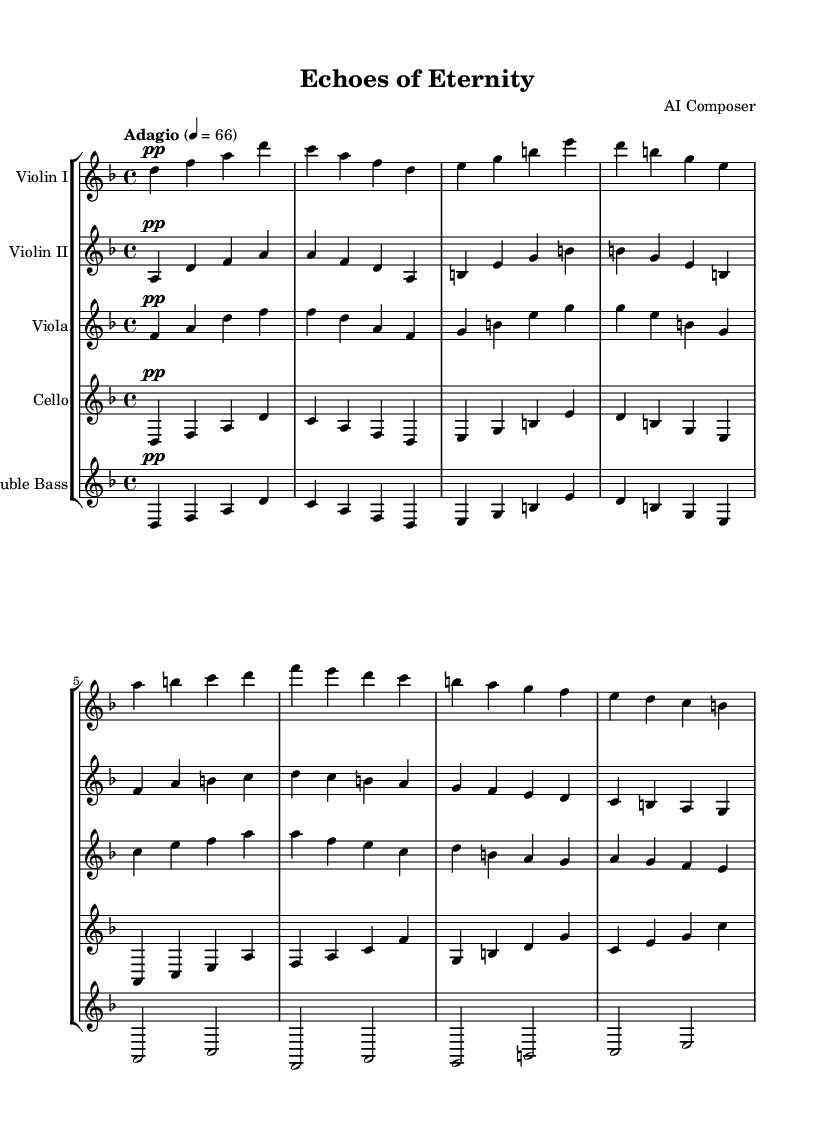What is the key signature of this music? The key signature of the piece is D minor, which has one flat (B flat). This can be identified by looking at the beginning of the staff where the key signature is indicated.
Answer: D minor What is the time signature of this music? The time signature is 4/4, shown directly after the key signature at the beginning of the score. This indicates there are four beats in each measure and a quarter note receives one beat.
Answer: 4/4 What is the tempo marking for this piece? The tempo marking is "Adagio," which is indicated at the top of the score. This marking suggests a slow pace, typically around 66 beats per minute.
Answer: Adagio What instruments are featured in this symphony? The instruments listed in the score are Violin I, Violin II, Viola, Cello, and Double Bass. Each instrument has its own staff in the score layout.
Answer: Violin I, Violin II, Viola, Cello, Double Bass Which voice has the highest pitch range in this piece? The Violin I typically plays in the highest pitch range among the given instruments. Observing the melodic lines, the notes played by Violin I are positioned higher on the staff compared to others.
Answer: Violin I How many measures are there in the provided score? There are 16 measures total, as can be counted from the beginning to the end of the provided music notation. Each measure is separated by vertical lines.
Answer: 16 